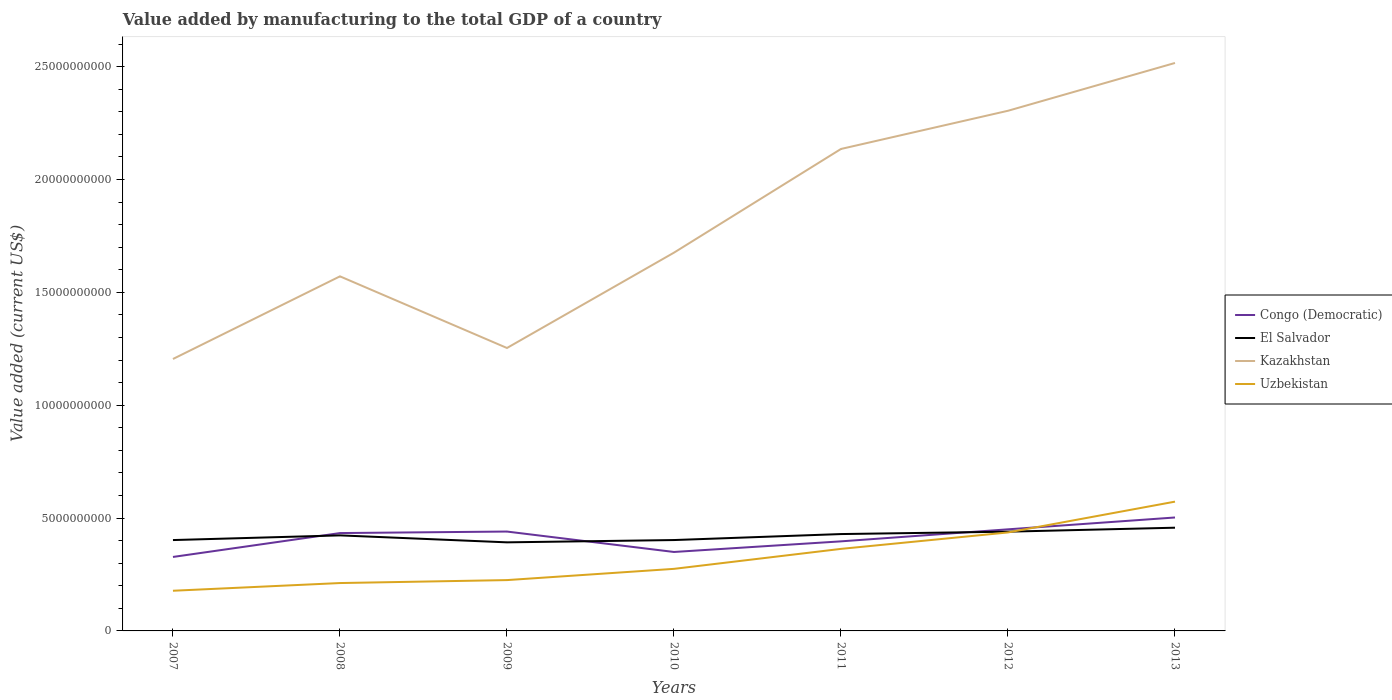Is the number of lines equal to the number of legend labels?
Offer a terse response. Yes. Across all years, what is the maximum value added by manufacturing to the total GDP in El Salvador?
Make the answer very short. 3.92e+09. What is the total value added by manufacturing to the total GDP in Congo (Democratic) in the graph?
Offer a terse response. -6.72e+07. What is the difference between the highest and the second highest value added by manufacturing to the total GDP in Kazakhstan?
Provide a succinct answer. 1.31e+1. Is the value added by manufacturing to the total GDP in El Salvador strictly greater than the value added by manufacturing to the total GDP in Uzbekistan over the years?
Ensure brevity in your answer.  No. How many lines are there?
Ensure brevity in your answer.  4. How many years are there in the graph?
Your answer should be compact. 7. What is the difference between two consecutive major ticks on the Y-axis?
Your answer should be very brief. 5.00e+09. Does the graph contain any zero values?
Provide a succinct answer. No. Does the graph contain grids?
Give a very brief answer. No. Where does the legend appear in the graph?
Give a very brief answer. Center right. What is the title of the graph?
Your answer should be compact. Value added by manufacturing to the total GDP of a country. What is the label or title of the X-axis?
Give a very brief answer. Years. What is the label or title of the Y-axis?
Your answer should be compact. Value added (current US$). What is the Value added (current US$) in Congo (Democratic) in 2007?
Provide a short and direct response. 3.28e+09. What is the Value added (current US$) in El Salvador in 2007?
Make the answer very short. 4.03e+09. What is the Value added (current US$) of Kazakhstan in 2007?
Your answer should be compact. 1.20e+1. What is the Value added (current US$) of Uzbekistan in 2007?
Offer a terse response. 1.78e+09. What is the Value added (current US$) in Congo (Democratic) in 2008?
Your answer should be compact. 4.34e+09. What is the Value added (current US$) of El Salvador in 2008?
Offer a terse response. 4.23e+09. What is the Value added (current US$) in Kazakhstan in 2008?
Your answer should be very brief. 1.57e+1. What is the Value added (current US$) in Uzbekistan in 2008?
Your response must be concise. 2.12e+09. What is the Value added (current US$) in Congo (Democratic) in 2009?
Your answer should be very brief. 4.40e+09. What is the Value added (current US$) of El Salvador in 2009?
Your response must be concise. 3.92e+09. What is the Value added (current US$) in Kazakhstan in 2009?
Ensure brevity in your answer.  1.25e+1. What is the Value added (current US$) of Uzbekistan in 2009?
Provide a succinct answer. 2.25e+09. What is the Value added (current US$) of Congo (Democratic) in 2010?
Your answer should be very brief. 3.50e+09. What is the Value added (current US$) in El Salvador in 2010?
Make the answer very short. 4.03e+09. What is the Value added (current US$) in Kazakhstan in 2010?
Ensure brevity in your answer.  1.68e+1. What is the Value added (current US$) in Uzbekistan in 2010?
Ensure brevity in your answer.  2.75e+09. What is the Value added (current US$) of Congo (Democratic) in 2011?
Your answer should be very brief. 3.97e+09. What is the Value added (current US$) of El Salvador in 2011?
Provide a short and direct response. 4.29e+09. What is the Value added (current US$) of Kazakhstan in 2011?
Your answer should be very brief. 2.14e+1. What is the Value added (current US$) in Uzbekistan in 2011?
Ensure brevity in your answer.  3.64e+09. What is the Value added (current US$) in Congo (Democratic) in 2012?
Make the answer very short. 4.50e+09. What is the Value added (current US$) of El Salvador in 2012?
Ensure brevity in your answer.  4.40e+09. What is the Value added (current US$) of Kazakhstan in 2012?
Your answer should be very brief. 2.30e+1. What is the Value added (current US$) of Uzbekistan in 2012?
Your response must be concise. 4.36e+09. What is the Value added (current US$) in Congo (Democratic) in 2013?
Offer a terse response. 5.03e+09. What is the Value added (current US$) in El Salvador in 2013?
Provide a succinct answer. 4.57e+09. What is the Value added (current US$) of Kazakhstan in 2013?
Offer a terse response. 2.52e+1. What is the Value added (current US$) in Uzbekistan in 2013?
Give a very brief answer. 5.73e+09. Across all years, what is the maximum Value added (current US$) in Congo (Democratic)?
Provide a succinct answer. 5.03e+09. Across all years, what is the maximum Value added (current US$) of El Salvador?
Keep it short and to the point. 4.57e+09. Across all years, what is the maximum Value added (current US$) in Kazakhstan?
Offer a very short reply. 2.52e+1. Across all years, what is the maximum Value added (current US$) of Uzbekistan?
Your answer should be compact. 5.73e+09. Across all years, what is the minimum Value added (current US$) in Congo (Democratic)?
Keep it short and to the point. 3.28e+09. Across all years, what is the minimum Value added (current US$) of El Salvador?
Your response must be concise. 3.92e+09. Across all years, what is the minimum Value added (current US$) of Kazakhstan?
Keep it short and to the point. 1.20e+1. Across all years, what is the minimum Value added (current US$) in Uzbekistan?
Provide a succinct answer. 1.78e+09. What is the total Value added (current US$) of Congo (Democratic) in the graph?
Your answer should be compact. 2.90e+1. What is the total Value added (current US$) in El Salvador in the graph?
Provide a short and direct response. 2.95e+1. What is the total Value added (current US$) in Kazakhstan in the graph?
Your answer should be very brief. 1.27e+11. What is the total Value added (current US$) in Uzbekistan in the graph?
Offer a very short reply. 2.26e+1. What is the difference between the Value added (current US$) of Congo (Democratic) in 2007 and that in 2008?
Your answer should be very brief. -1.06e+09. What is the difference between the Value added (current US$) in El Salvador in 2007 and that in 2008?
Your answer should be very brief. -2.08e+08. What is the difference between the Value added (current US$) of Kazakhstan in 2007 and that in 2008?
Your answer should be very brief. -3.66e+09. What is the difference between the Value added (current US$) in Uzbekistan in 2007 and that in 2008?
Provide a short and direct response. -3.41e+08. What is the difference between the Value added (current US$) of Congo (Democratic) in 2007 and that in 2009?
Provide a succinct answer. -1.13e+09. What is the difference between the Value added (current US$) in El Salvador in 2007 and that in 2009?
Keep it short and to the point. 1.01e+08. What is the difference between the Value added (current US$) in Kazakhstan in 2007 and that in 2009?
Keep it short and to the point. -4.88e+08. What is the difference between the Value added (current US$) in Uzbekistan in 2007 and that in 2009?
Offer a very short reply. -4.72e+08. What is the difference between the Value added (current US$) in Congo (Democratic) in 2007 and that in 2010?
Offer a very short reply. -2.21e+08. What is the difference between the Value added (current US$) of El Salvador in 2007 and that in 2010?
Give a very brief answer. -9.00e+05. What is the difference between the Value added (current US$) in Kazakhstan in 2007 and that in 2010?
Ensure brevity in your answer.  -4.71e+09. What is the difference between the Value added (current US$) in Uzbekistan in 2007 and that in 2010?
Provide a short and direct response. -9.70e+08. What is the difference between the Value added (current US$) of Congo (Democratic) in 2007 and that in 2011?
Offer a very short reply. -6.91e+08. What is the difference between the Value added (current US$) in El Salvador in 2007 and that in 2011?
Offer a terse response. -2.66e+08. What is the difference between the Value added (current US$) of Kazakhstan in 2007 and that in 2011?
Offer a terse response. -9.31e+09. What is the difference between the Value added (current US$) in Uzbekistan in 2007 and that in 2011?
Your response must be concise. -1.85e+09. What is the difference between the Value added (current US$) of Congo (Democratic) in 2007 and that in 2012?
Offer a very short reply. -1.22e+09. What is the difference between the Value added (current US$) of El Salvador in 2007 and that in 2012?
Offer a very short reply. -3.72e+08. What is the difference between the Value added (current US$) of Kazakhstan in 2007 and that in 2012?
Your answer should be compact. -1.10e+1. What is the difference between the Value added (current US$) in Uzbekistan in 2007 and that in 2012?
Provide a short and direct response. -2.58e+09. What is the difference between the Value added (current US$) of Congo (Democratic) in 2007 and that in 2013?
Offer a terse response. -1.75e+09. What is the difference between the Value added (current US$) of El Salvador in 2007 and that in 2013?
Offer a terse response. -5.48e+08. What is the difference between the Value added (current US$) in Kazakhstan in 2007 and that in 2013?
Provide a succinct answer. -1.31e+1. What is the difference between the Value added (current US$) of Uzbekistan in 2007 and that in 2013?
Provide a succinct answer. -3.95e+09. What is the difference between the Value added (current US$) of Congo (Democratic) in 2008 and that in 2009?
Your answer should be very brief. -6.72e+07. What is the difference between the Value added (current US$) in El Salvador in 2008 and that in 2009?
Keep it short and to the point. 3.09e+08. What is the difference between the Value added (current US$) of Kazakhstan in 2008 and that in 2009?
Your response must be concise. 3.17e+09. What is the difference between the Value added (current US$) in Uzbekistan in 2008 and that in 2009?
Keep it short and to the point. -1.31e+08. What is the difference between the Value added (current US$) in Congo (Democratic) in 2008 and that in 2010?
Provide a succinct answer. 8.37e+08. What is the difference between the Value added (current US$) of El Salvador in 2008 and that in 2010?
Offer a terse response. 2.07e+08. What is the difference between the Value added (current US$) in Kazakhstan in 2008 and that in 2010?
Ensure brevity in your answer.  -1.05e+09. What is the difference between the Value added (current US$) of Uzbekistan in 2008 and that in 2010?
Provide a succinct answer. -6.29e+08. What is the difference between the Value added (current US$) in Congo (Democratic) in 2008 and that in 2011?
Provide a short and direct response. 3.67e+08. What is the difference between the Value added (current US$) in El Salvador in 2008 and that in 2011?
Your answer should be very brief. -5.81e+07. What is the difference between the Value added (current US$) in Kazakhstan in 2008 and that in 2011?
Offer a very short reply. -5.64e+09. What is the difference between the Value added (current US$) in Uzbekistan in 2008 and that in 2011?
Your response must be concise. -1.51e+09. What is the difference between the Value added (current US$) of Congo (Democratic) in 2008 and that in 2012?
Your answer should be very brief. -1.66e+08. What is the difference between the Value added (current US$) of El Salvador in 2008 and that in 2012?
Give a very brief answer. -1.64e+08. What is the difference between the Value added (current US$) in Kazakhstan in 2008 and that in 2012?
Give a very brief answer. -7.34e+09. What is the difference between the Value added (current US$) in Uzbekistan in 2008 and that in 2012?
Ensure brevity in your answer.  -2.24e+09. What is the difference between the Value added (current US$) of Congo (Democratic) in 2008 and that in 2013?
Offer a very short reply. -6.91e+08. What is the difference between the Value added (current US$) of El Salvador in 2008 and that in 2013?
Your answer should be very brief. -3.40e+08. What is the difference between the Value added (current US$) of Kazakhstan in 2008 and that in 2013?
Offer a very short reply. -9.45e+09. What is the difference between the Value added (current US$) in Uzbekistan in 2008 and that in 2013?
Give a very brief answer. -3.61e+09. What is the difference between the Value added (current US$) in Congo (Democratic) in 2009 and that in 2010?
Provide a short and direct response. 9.05e+08. What is the difference between the Value added (current US$) of El Salvador in 2009 and that in 2010?
Provide a short and direct response. -1.02e+08. What is the difference between the Value added (current US$) in Kazakhstan in 2009 and that in 2010?
Your response must be concise. -4.22e+09. What is the difference between the Value added (current US$) of Uzbekistan in 2009 and that in 2010?
Your answer should be compact. -4.98e+08. What is the difference between the Value added (current US$) in Congo (Democratic) in 2009 and that in 2011?
Offer a very short reply. 4.34e+08. What is the difference between the Value added (current US$) of El Salvador in 2009 and that in 2011?
Give a very brief answer. -3.67e+08. What is the difference between the Value added (current US$) in Kazakhstan in 2009 and that in 2011?
Your answer should be very brief. -8.82e+09. What is the difference between the Value added (current US$) in Uzbekistan in 2009 and that in 2011?
Your answer should be compact. -1.38e+09. What is the difference between the Value added (current US$) of Congo (Democratic) in 2009 and that in 2012?
Your answer should be very brief. -9.88e+07. What is the difference between the Value added (current US$) in El Salvador in 2009 and that in 2012?
Your answer should be compact. -4.73e+08. What is the difference between the Value added (current US$) in Kazakhstan in 2009 and that in 2012?
Provide a succinct answer. -1.05e+1. What is the difference between the Value added (current US$) in Uzbekistan in 2009 and that in 2012?
Give a very brief answer. -2.11e+09. What is the difference between the Value added (current US$) of Congo (Democratic) in 2009 and that in 2013?
Your answer should be very brief. -6.24e+08. What is the difference between the Value added (current US$) of El Salvador in 2009 and that in 2013?
Your answer should be very brief. -6.49e+08. What is the difference between the Value added (current US$) in Kazakhstan in 2009 and that in 2013?
Your answer should be very brief. -1.26e+1. What is the difference between the Value added (current US$) in Uzbekistan in 2009 and that in 2013?
Provide a succinct answer. -3.48e+09. What is the difference between the Value added (current US$) in Congo (Democratic) in 2010 and that in 2011?
Your answer should be compact. -4.70e+08. What is the difference between the Value added (current US$) of El Salvador in 2010 and that in 2011?
Ensure brevity in your answer.  -2.65e+08. What is the difference between the Value added (current US$) of Kazakhstan in 2010 and that in 2011?
Provide a succinct answer. -4.59e+09. What is the difference between the Value added (current US$) of Uzbekistan in 2010 and that in 2011?
Offer a very short reply. -8.85e+08. What is the difference between the Value added (current US$) of Congo (Democratic) in 2010 and that in 2012?
Provide a short and direct response. -1.00e+09. What is the difference between the Value added (current US$) of El Salvador in 2010 and that in 2012?
Your response must be concise. -3.71e+08. What is the difference between the Value added (current US$) of Kazakhstan in 2010 and that in 2012?
Offer a terse response. -6.29e+09. What is the difference between the Value added (current US$) in Uzbekistan in 2010 and that in 2012?
Provide a short and direct response. -1.61e+09. What is the difference between the Value added (current US$) of Congo (Democratic) in 2010 and that in 2013?
Offer a terse response. -1.53e+09. What is the difference between the Value added (current US$) of El Salvador in 2010 and that in 2013?
Provide a short and direct response. -5.47e+08. What is the difference between the Value added (current US$) of Kazakhstan in 2010 and that in 2013?
Make the answer very short. -8.41e+09. What is the difference between the Value added (current US$) in Uzbekistan in 2010 and that in 2013?
Offer a very short reply. -2.98e+09. What is the difference between the Value added (current US$) of Congo (Democratic) in 2011 and that in 2012?
Your response must be concise. -5.33e+08. What is the difference between the Value added (current US$) of El Salvador in 2011 and that in 2012?
Offer a terse response. -1.06e+08. What is the difference between the Value added (current US$) in Kazakhstan in 2011 and that in 2012?
Offer a very short reply. -1.69e+09. What is the difference between the Value added (current US$) in Uzbekistan in 2011 and that in 2012?
Ensure brevity in your answer.  -7.29e+08. What is the difference between the Value added (current US$) in Congo (Democratic) in 2011 and that in 2013?
Ensure brevity in your answer.  -1.06e+09. What is the difference between the Value added (current US$) in El Salvador in 2011 and that in 2013?
Provide a succinct answer. -2.82e+08. What is the difference between the Value added (current US$) in Kazakhstan in 2011 and that in 2013?
Provide a short and direct response. -3.81e+09. What is the difference between the Value added (current US$) of Uzbekistan in 2011 and that in 2013?
Give a very brief answer. -2.09e+09. What is the difference between the Value added (current US$) of Congo (Democratic) in 2012 and that in 2013?
Your response must be concise. -5.25e+08. What is the difference between the Value added (current US$) of El Salvador in 2012 and that in 2013?
Your answer should be compact. -1.76e+08. What is the difference between the Value added (current US$) of Kazakhstan in 2012 and that in 2013?
Your answer should be very brief. -2.12e+09. What is the difference between the Value added (current US$) of Uzbekistan in 2012 and that in 2013?
Give a very brief answer. -1.36e+09. What is the difference between the Value added (current US$) of Congo (Democratic) in 2007 and the Value added (current US$) of El Salvador in 2008?
Offer a very short reply. -9.56e+08. What is the difference between the Value added (current US$) of Congo (Democratic) in 2007 and the Value added (current US$) of Kazakhstan in 2008?
Your answer should be very brief. -1.24e+1. What is the difference between the Value added (current US$) of Congo (Democratic) in 2007 and the Value added (current US$) of Uzbekistan in 2008?
Make the answer very short. 1.16e+09. What is the difference between the Value added (current US$) of El Salvador in 2007 and the Value added (current US$) of Kazakhstan in 2008?
Offer a very short reply. -1.17e+1. What is the difference between the Value added (current US$) of El Salvador in 2007 and the Value added (current US$) of Uzbekistan in 2008?
Provide a short and direct response. 1.90e+09. What is the difference between the Value added (current US$) of Kazakhstan in 2007 and the Value added (current US$) of Uzbekistan in 2008?
Ensure brevity in your answer.  9.93e+09. What is the difference between the Value added (current US$) in Congo (Democratic) in 2007 and the Value added (current US$) in El Salvador in 2009?
Your answer should be very brief. -6.47e+08. What is the difference between the Value added (current US$) in Congo (Democratic) in 2007 and the Value added (current US$) in Kazakhstan in 2009?
Ensure brevity in your answer.  -9.26e+09. What is the difference between the Value added (current US$) of Congo (Democratic) in 2007 and the Value added (current US$) of Uzbekistan in 2009?
Your answer should be compact. 1.03e+09. What is the difference between the Value added (current US$) of El Salvador in 2007 and the Value added (current US$) of Kazakhstan in 2009?
Provide a succinct answer. -8.51e+09. What is the difference between the Value added (current US$) in El Salvador in 2007 and the Value added (current US$) in Uzbekistan in 2009?
Offer a terse response. 1.77e+09. What is the difference between the Value added (current US$) of Kazakhstan in 2007 and the Value added (current US$) of Uzbekistan in 2009?
Your answer should be very brief. 9.80e+09. What is the difference between the Value added (current US$) of Congo (Democratic) in 2007 and the Value added (current US$) of El Salvador in 2010?
Ensure brevity in your answer.  -7.49e+08. What is the difference between the Value added (current US$) of Congo (Democratic) in 2007 and the Value added (current US$) of Kazakhstan in 2010?
Your answer should be compact. -1.35e+1. What is the difference between the Value added (current US$) of Congo (Democratic) in 2007 and the Value added (current US$) of Uzbekistan in 2010?
Keep it short and to the point. 5.27e+08. What is the difference between the Value added (current US$) of El Salvador in 2007 and the Value added (current US$) of Kazakhstan in 2010?
Your answer should be compact. -1.27e+1. What is the difference between the Value added (current US$) of El Salvador in 2007 and the Value added (current US$) of Uzbekistan in 2010?
Give a very brief answer. 1.28e+09. What is the difference between the Value added (current US$) in Kazakhstan in 2007 and the Value added (current US$) in Uzbekistan in 2010?
Your response must be concise. 9.30e+09. What is the difference between the Value added (current US$) of Congo (Democratic) in 2007 and the Value added (current US$) of El Salvador in 2011?
Give a very brief answer. -1.01e+09. What is the difference between the Value added (current US$) of Congo (Democratic) in 2007 and the Value added (current US$) of Kazakhstan in 2011?
Offer a very short reply. -1.81e+1. What is the difference between the Value added (current US$) in Congo (Democratic) in 2007 and the Value added (current US$) in Uzbekistan in 2011?
Your answer should be very brief. -3.57e+08. What is the difference between the Value added (current US$) in El Salvador in 2007 and the Value added (current US$) in Kazakhstan in 2011?
Your response must be concise. -1.73e+1. What is the difference between the Value added (current US$) of El Salvador in 2007 and the Value added (current US$) of Uzbekistan in 2011?
Make the answer very short. 3.91e+08. What is the difference between the Value added (current US$) in Kazakhstan in 2007 and the Value added (current US$) in Uzbekistan in 2011?
Offer a very short reply. 8.41e+09. What is the difference between the Value added (current US$) of Congo (Democratic) in 2007 and the Value added (current US$) of El Salvador in 2012?
Offer a terse response. -1.12e+09. What is the difference between the Value added (current US$) in Congo (Democratic) in 2007 and the Value added (current US$) in Kazakhstan in 2012?
Keep it short and to the point. -1.98e+1. What is the difference between the Value added (current US$) of Congo (Democratic) in 2007 and the Value added (current US$) of Uzbekistan in 2012?
Offer a terse response. -1.09e+09. What is the difference between the Value added (current US$) of El Salvador in 2007 and the Value added (current US$) of Kazakhstan in 2012?
Give a very brief answer. -1.90e+1. What is the difference between the Value added (current US$) in El Salvador in 2007 and the Value added (current US$) in Uzbekistan in 2012?
Ensure brevity in your answer.  -3.38e+08. What is the difference between the Value added (current US$) of Kazakhstan in 2007 and the Value added (current US$) of Uzbekistan in 2012?
Your response must be concise. 7.69e+09. What is the difference between the Value added (current US$) of Congo (Democratic) in 2007 and the Value added (current US$) of El Salvador in 2013?
Keep it short and to the point. -1.30e+09. What is the difference between the Value added (current US$) of Congo (Democratic) in 2007 and the Value added (current US$) of Kazakhstan in 2013?
Give a very brief answer. -2.19e+1. What is the difference between the Value added (current US$) of Congo (Democratic) in 2007 and the Value added (current US$) of Uzbekistan in 2013?
Your answer should be compact. -2.45e+09. What is the difference between the Value added (current US$) of El Salvador in 2007 and the Value added (current US$) of Kazakhstan in 2013?
Give a very brief answer. -2.11e+1. What is the difference between the Value added (current US$) of El Salvador in 2007 and the Value added (current US$) of Uzbekistan in 2013?
Ensure brevity in your answer.  -1.70e+09. What is the difference between the Value added (current US$) in Kazakhstan in 2007 and the Value added (current US$) in Uzbekistan in 2013?
Your answer should be very brief. 6.32e+09. What is the difference between the Value added (current US$) in Congo (Democratic) in 2008 and the Value added (current US$) in El Salvador in 2009?
Offer a very short reply. 4.11e+08. What is the difference between the Value added (current US$) of Congo (Democratic) in 2008 and the Value added (current US$) of Kazakhstan in 2009?
Give a very brief answer. -8.20e+09. What is the difference between the Value added (current US$) in Congo (Democratic) in 2008 and the Value added (current US$) in Uzbekistan in 2009?
Your response must be concise. 2.08e+09. What is the difference between the Value added (current US$) in El Salvador in 2008 and the Value added (current US$) in Kazakhstan in 2009?
Keep it short and to the point. -8.30e+09. What is the difference between the Value added (current US$) in El Salvador in 2008 and the Value added (current US$) in Uzbekistan in 2009?
Provide a succinct answer. 1.98e+09. What is the difference between the Value added (current US$) of Kazakhstan in 2008 and the Value added (current US$) of Uzbekistan in 2009?
Ensure brevity in your answer.  1.35e+1. What is the difference between the Value added (current US$) in Congo (Democratic) in 2008 and the Value added (current US$) in El Salvador in 2010?
Provide a succinct answer. 3.09e+08. What is the difference between the Value added (current US$) of Congo (Democratic) in 2008 and the Value added (current US$) of Kazakhstan in 2010?
Offer a very short reply. -1.24e+1. What is the difference between the Value added (current US$) in Congo (Democratic) in 2008 and the Value added (current US$) in Uzbekistan in 2010?
Your answer should be very brief. 1.59e+09. What is the difference between the Value added (current US$) of El Salvador in 2008 and the Value added (current US$) of Kazakhstan in 2010?
Your answer should be very brief. -1.25e+1. What is the difference between the Value added (current US$) of El Salvador in 2008 and the Value added (current US$) of Uzbekistan in 2010?
Your answer should be very brief. 1.48e+09. What is the difference between the Value added (current US$) in Kazakhstan in 2008 and the Value added (current US$) in Uzbekistan in 2010?
Give a very brief answer. 1.30e+1. What is the difference between the Value added (current US$) of Congo (Democratic) in 2008 and the Value added (current US$) of El Salvador in 2011?
Give a very brief answer. 4.42e+07. What is the difference between the Value added (current US$) in Congo (Democratic) in 2008 and the Value added (current US$) in Kazakhstan in 2011?
Your answer should be very brief. -1.70e+1. What is the difference between the Value added (current US$) of Congo (Democratic) in 2008 and the Value added (current US$) of Uzbekistan in 2011?
Give a very brief answer. 7.01e+08. What is the difference between the Value added (current US$) of El Salvador in 2008 and the Value added (current US$) of Kazakhstan in 2011?
Provide a succinct answer. -1.71e+1. What is the difference between the Value added (current US$) in El Salvador in 2008 and the Value added (current US$) in Uzbekistan in 2011?
Provide a short and direct response. 5.98e+08. What is the difference between the Value added (current US$) in Kazakhstan in 2008 and the Value added (current US$) in Uzbekistan in 2011?
Keep it short and to the point. 1.21e+1. What is the difference between the Value added (current US$) of Congo (Democratic) in 2008 and the Value added (current US$) of El Salvador in 2012?
Make the answer very short. -6.17e+07. What is the difference between the Value added (current US$) in Congo (Democratic) in 2008 and the Value added (current US$) in Kazakhstan in 2012?
Provide a short and direct response. -1.87e+1. What is the difference between the Value added (current US$) in Congo (Democratic) in 2008 and the Value added (current US$) in Uzbekistan in 2012?
Provide a short and direct response. -2.77e+07. What is the difference between the Value added (current US$) in El Salvador in 2008 and the Value added (current US$) in Kazakhstan in 2012?
Your answer should be very brief. -1.88e+1. What is the difference between the Value added (current US$) of El Salvador in 2008 and the Value added (current US$) of Uzbekistan in 2012?
Provide a succinct answer. -1.30e+08. What is the difference between the Value added (current US$) in Kazakhstan in 2008 and the Value added (current US$) in Uzbekistan in 2012?
Ensure brevity in your answer.  1.13e+1. What is the difference between the Value added (current US$) in Congo (Democratic) in 2008 and the Value added (current US$) in El Salvador in 2013?
Make the answer very short. -2.38e+08. What is the difference between the Value added (current US$) of Congo (Democratic) in 2008 and the Value added (current US$) of Kazakhstan in 2013?
Offer a terse response. -2.08e+1. What is the difference between the Value added (current US$) in Congo (Democratic) in 2008 and the Value added (current US$) in Uzbekistan in 2013?
Your answer should be very brief. -1.39e+09. What is the difference between the Value added (current US$) of El Salvador in 2008 and the Value added (current US$) of Kazakhstan in 2013?
Give a very brief answer. -2.09e+1. What is the difference between the Value added (current US$) in El Salvador in 2008 and the Value added (current US$) in Uzbekistan in 2013?
Provide a succinct answer. -1.49e+09. What is the difference between the Value added (current US$) of Kazakhstan in 2008 and the Value added (current US$) of Uzbekistan in 2013?
Make the answer very short. 9.98e+09. What is the difference between the Value added (current US$) in Congo (Democratic) in 2009 and the Value added (current US$) in El Salvador in 2010?
Provide a succinct answer. 3.76e+08. What is the difference between the Value added (current US$) in Congo (Democratic) in 2009 and the Value added (current US$) in Kazakhstan in 2010?
Keep it short and to the point. -1.24e+1. What is the difference between the Value added (current US$) of Congo (Democratic) in 2009 and the Value added (current US$) of Uzbekistan in 2010?
Provide a succinct answer. 1.65e+09. What is the difference between the Value added (current US$) in El Salvador in 2009 and the Value added (current US$) in Kazakhstan in 2010?
Make the answer very short. -1.28e+1. What is the difference between the Value added (current US$) in El Salvador in 2009 and the Value added (current US$) in Uzbekistan in 2010?
Make the answer very short. 1.17e+09. What is the difference between the Value added (current US$) in Kazakhstan in 2009 and the Value added (current US$) in Uzbekistan in 2010?
Your response must be concise. 9.79e+09. What is the difference between the Value added (current US$) of Congo (Democratic) in 2009 and the Value added (current US$) of El Salvador in 2011?
Ensure brevity in your answer.  1.11e+08. What is the difference between the Value added (current US$) of Congo (Democratic) in 2009 and the Value added (current US$) of Kazakhstan in 2011?
Your answer should be very brief. -1.70e+1. What is the difference between the Value added (current US$) of Congo (Democratic) in 2009 and the Value added (current US$) of Uzbekistan in 2011?
Keep it short and to the point. 7.68e+08. What is the difference between the Value added (current US$) of El Salvador in 2009 and the Value added (current US$) of Kazakhstan in 2011?
Make the answer very short. -1.74e+1. What is the difference between the Value added (current US$) in El Salvador in 2009 and the Value added (current US$) in Uzbekistan in 2011?
Provide a short and direct response. 2.90e+08. What is the difference between the Value added (current US$) in Kazakhstan in 2009 and the Value added (current US$) in Uzbekistan in 2011?
Your response must be concise. 8.90e+09. What is the difference between the Value added (current US$) of Congo (Democratic) in 2009 and the Value added (current US$) of El Salvador in 2012?
Ensure brevity in your answer.  5.52e+06. What is the difference between the Value added (current US$) of Congo (Democratic) in 2009 and the Value added (current US$) of Kazakhstan in 2012?
Provide a succinct answer. -1.86e+1. What is the difference between the Value added (current US$) in Congo (Democratic) in 2009 and the Value added (current US$) in Uzbekistan in 2012?
Keep it short and to the point. 3.95e+07. What is the difference between the Value added (current US$) of El Salvador in 2009 and the Value added (current US$) of Kazakhstan in 2012?
Make the answer very short. -1.91e+1. What is the difference between the Value added (current US$) in El Salvador in 2009 and the Value added (current US$) in Uzbekistan in 2012?
Ensure brevity in your answer.  -4.39e+08. What is the difference between the Value added (current US$) in Kazakhstan in 2009 and the Value added (current US$) in Uzbekistan in 2012?
Your response must be concise. 8.17e+09. What is the difference between the Value added (current US$) of Congo (Democratic) in 2009 and the Value added (current US$) of El Salvador in 2013?
Keep it short and to the point. -1.71e+08. What is the difference between the Value added (current US$) in Congo (Democratic) in 2009 and the Value added (current US$) in Kazakhstan in 2013?
Provide a short and direct response. -2.08e+1. What is the difference between the Value added (current US$) in Congo (Democratic) in 2009 and the Value added (current US$) in Uzbekistan in 2013?
Your answer should be compact. -1.33e+09. What is the difference between the Value added (current US$) of El Salvador in 2009 and the Value added (current US$) of Kazakhstan in 2013?
Your answer should be very brief. -2.12e+1. What is the difference between the Value added (current US$) in El Salvador in 2009 and the Value added (current US$) in Uzbekistan in 2013?
Provide a short and direct response. -1.80e+09. What is the difference between the Value added (current US$) in Kazakhstan in 2009 and the Value added (current US$) in Uzbekistan in 2013?
Make the answer very short. 6.81e+09. What is the difference between the Value added (current US$) of Congo (Democratic) in 2010 and the Value added (current US$) of El Salvador in 2011?
Your answer should be very brief. -7.93e+08. What is the difference between the Value added (current US$) of Congo (Democratic) in 2010 and the Value added (current US$) of Kazakhstan in 2011?
Your response must be concise. -1.79e+1. What is the difference between the Value added (current US$) of Congo (Democratic) in 2010 and the Value added (current US$) of Uzbekistan in 2011?
Provide a succinct answer. -1.37e+08. What is the difference between the Value added (current US$) in El Salvador in 2010 and the Value added (current US$) in Kazakhstan in 2011?
Offer a terse response. -1.73e+1. What is the difference between the Value added (current US$) of El Salvador in 2010 and the Value added (current US$) of Uzbekistan in 2011?
Provide a succinct answer. 3.92e+08. What is the difference between the Value added (current US$) in Kazakhstan in 2010 and the Value added (current US$) in Uzbekistan in 2011?
Offer a very short reply. 1.31e+1. What is the difference between the Value added (current US$) in Congo (Democratic) in 2010 and the Value added (current US$) in El Salvador in 2012?
Ensure brevity in your answer.  -8.99e+08. What is the difference between the Value added (current US$) in Congo (Democratic) in 2010 and the Value added (current US$) in Kazakhstan in 2012?
Offer a very short reply. -1.95e+1. What is the difference between the Value added (current US$) of Congo (Democratic) in 2010 and the Value added (current US$) of Uzbekistan in 2012?
Give a very brief answer. -8.65e+08. What is the difference between the Value added (current US$) of El Salvador in 2010 and the Value added (current US$) of Kazakhstan in 2012?
Your answer should be very brief. -1.90e+1. What is the difference between the Value added (current US$) of El Salvador in 2010 and the Value added (current US$) of Uzbekistan in 2012?
Offer a terse response. -3.37e+08. What is the difference between the Value added (current US$) of Kazakhstan in 2010 and the Value added (current US$) of Uzbekistan in 2012?
Ensure brevity in your answer.  1.24e+1. What is the difference between the Value added (current US$) of Congo (Democratic) in 2010 and the Value added (current US$) of El Salvador in 2013?
Your answer should be compact. -1.08e+09. What is the difference between the Value added (current US$) in Congo (Democratic) in 2010 and the Value added (current US$) in Kazakhstan in 2013?
Make the answer very short. -2.17e+1. What is the difference between the Value added (current US$) of Congo (Democratic) in 2010 and the Value added (current US$) of Uzbekistan in 2013?
Offer a very short reply. -2.23e+09. What is the difference between the Value added (current US$) of El Salvador in 2010 and the Value added (current US$) of Kazakhstan in 2013?
Offer a very short reply. -2.11e+1. What is the difference between the Value added (current US$) of El Salvador in 2010 and the Value added (current US$) of Uzbekistan in 2013?
Provide a succinct answer. -1.70e+09. What is the difference between the Value added (current US$) of Kazakhstan in 2010 and the Value added (current US$) of Uzbekistan in 2013?
Offer a very short reply. 1.10e+1. What is the difference between the Value added (current US$) of Congo (Democratic) in 2011 and the Value added (current US$) of El Salvador in 2012?
Offer a very short reply. -4.29e+08. What is the difference between the Value added (current US$) of Congo (Democratic) in 2011 and the Value added (current US$) of Kazakhstan in 2012?
Keep it short and to the point. -1.91e+1. What is the difference between the Value added (current US$) in Congo (Democratic) in 2011 and the Value added (current US$) in Uzbekistan in 2012?
Make the answer very short. -3.95e+08. What is the difference between the Value added (current US$) in El Salvador in 2011 and the Value added (current US$) in Kazakhstan in 2012?
Provide a short and direct response. -1.88e+1. What is the difference between the Value added (current US$) of El Salvador in 2011 and the Value added (current US$) of Uzbekistan in 2012?
Provide a succinct answer. -7.20e+07. What is the difference between the Value added (current US$) in Kazakhstan in 2011 and the Value added (current US$) in Uzbekistan in 2012?
Offer a very short reply. 1.70e+1. What is the difference between the Value added (current US$) in Congo (Democratic) in 2011 and the Value added (current US$) in El Salvador in 2013?
Offer a terse response. -6.05e+08. What is the difference between the Value added (current US$) of Congo (Democratic) in 2011 and the Value added (current US$) of Kazakhstan in 2013?
Make the answer very short. -2.12e+1. What is the difference between the Value added (current US$) in Congo (Democratic) in 2011 and the Value added (current US$) in Uzbekistan in 2013?
Your answer should be very brief. -1.76e+09. What is the difference between the Value added (current US$) of El Salvador in 2011 and the Value added (current US$) of Kazakhstan in 2013?
Ensure brevity in your answer.  -2.09e+1. What is the difference between the Value added (current US$) of El Salvador in 2011 and the Value added (current US$) of Uzbekistan in 2013?
Your answer should be compact. -1.44e+09. What is the difference between the Value added (current US$) in Kazakhstan in 2011 and the Value added (current US$) in Uzbekistan in 2013?
Your answer should be very brief. 1.56e+1. What is the difference between the Value added (current US$) in Congo (Democratic) in 2012 and the Value added (current US$) in El Salvador in 2013?
Keep it short and to the point. -7.18e+07. What is the difference between the Value added (current US$) of Congo (Democratic) in 2012 and the Value added (current US$) of Kazakhstan in 2013?
Give a very brief answer. -2.07e+1. What is the difference between the Value added (current US$) of Congo (Democratic) in 2012 and the Value added (current US$) of Uzbekistan in 2013?
Offer a very short reply. -1.23e+09. What is the difference between the Value added (current US$) of El Salvador in 2012 and the Value added (current US$) of Kazakhstan in 2013?
Make the answer very short. -2.08e+1. What is the difference between the Value added (current US$) in El Salvador in 2012 and the Value added (current US$) in Uzbekistan in 2013?
Offer a terse response. -1.33e+09. What is the difference between the Value added (current US$) of Kazakhstan in 2012 and the Value added (current US$) of Uzbekistan in 2013?
Your answer should be compact. 1.73e+1. What is the average Value added (current US$) in Congo (Democratic) per year?
Provide a short and direct response. 4.14e+09. What is the average Value added (current US$) in El Salvador per year?
Offer a very short reply. 4.21e+09. What is the average Value added (current US$) in Kazakhstan per year?
Provide a succinct answer. 1.81e+1. What is the average Value added (current US$) of Uzbekistan per year?
Ensure brevity in your answer.  3.23e+09. In the year 2007, what is the difference between the Value added (current US$) in Congo (Democratic) and Value added (current US$) in El Salvador?
Make the answer very short. -7.48e+08. In the year 2007, what is the difference between the Value added (current US$) of Congo (Democratic) and Value added (current US$) of Kazakhstan?
Provide a short and direct response. -8.77e+09. In the year 2007, what is the difference between the Value added (current US$) of Congo (Democratic) and Value added (current US$) of Uzbekistan?
Give a very brief answer. 1.50e+09. In the year 2007, what is the difference between the Value added (current US$) of El Salvador and Value added (current US$) of Kazakhstan?
Your answer should be compact. -8.02e+09. In the year 2007, what is the difference between the Value added (current US$) in El Salvador and Value added (current US$) in Uzbekistan?
Offer a terse response. 2.25e+09. In the year 2007, what is the difference between the Value added (current US$) of Kazakhstan and Value added (current US$) of Uzbekistan?
Your answer should be very brief. 1.03e+1. In the year 2008, what is the difference between the Value added (current US$) in Congo (Democratic) and Value added (current US$) in El Salvador?
Offer a very short reply. 1.02e+08. In the year 2008, what is the difference between the Value added (current US$) in Congo (Democratic) and Value added (current US$) in Kazakhstan?
Your answer should be very brief. -1.14e+1. In the year 2008, what is the difference between the Value added (current US$) in Congo (Democratic) and Value added (current US$) in Uzbekistan?
Keep it short and to the point. 2.21e+09. In the year 2008, what is the difference between the Value added (current US$) in El Salvador and Value added (current US$) in Kazakhstan?
Give a very brief answer. -1.15e+1. In the year 2008, what is the difference between the Value added (current US$) of El Salvador and Value added (current US$) of Uzbekistan?
Give a very brief answer. 2.11e+09. In the year 2008, what is the difference between the Value added (current US$) in Kazakhstan and Value added (current US$) in Uzbekistan?
Ensure brevity in your answer.  1.36e+1. In the year 2009, what is the difference between the Value added (current US$) in Congo (Democratic) and Value added (current US$) in El Salvador?
Make the answer very short. 4.78e+08. In the year 2009, what is the difference between the Value added (current US$) in Congo (Democratic) and Value added (current US$) in Kazakhstan?
Give a very brief answer. -8.13e+09. In the year 2009, what is the difference between the Value added (current US$) of Congo (Democratic) and Value added (current US$) of Uzbekistan?
Your answer should be very brief. 2.15e+09. In the year 2009, what is the difference between the Value added (current US$) in El Salvador and Value added (current US$) in Kazakhstan?
Provide a short and direct response. -8.61e+09. In the year 2009, what is the difference between the Value added (current US$) of El Salvador and Value added (current US$) of Uzbekistan?
Offer a very short reply. 1.67e+09. In the year 2009, what is the difference between the Value added (current US$) of Kazakhstan and Value added (current US$) of Uzbekistan?
Your answer should be compact. 1.03e+1. In the year 2010, what is the difference between the Value added (current US$) in Congo (Democratic) and Value added (current US$) in El Salvador?
Keep it short and to the point. -5.29e+08. In the year 2010, what is the difference between the Value added (current US$) in Congo (Democratic) and Value added (current US$) in Kazakhstan?
Offer a terse response. -1.33e+1. In the year 2010, what is the difference between the Value added (current US$) of Congo (Democratic) and Value added (current US$) of Uzbekistan?
Your answer should be very brief. 7.48e+08. In the year 2010, what is the difference between the Value added (current US$) of El Salvador and Value added (current US$) of Kazakhstan?
Provide a short and direct response. -1.27e+1. In the year 2010, what is the difference between the Value added (current US$) of El Salvador and Value added (current US$) of Uzbekistan?
Give a very brief answer. 1.28e+09. In the year 2010, what is the difference between the Value added (current US$) of Kazakhstan and Value added (current US$) of Uzbekistan?
Offer a terse response. 1.40e+1. In the year 2011, what is the difference between the Value added (current US$) of Congo (Democratic) and Value added (current US$) of El Salvador?
Provide a short and direct response. -3.23e+08. In the year 2011, what is the difference between the Value added (current US$) in Congo (Democratic) and Value added (current US$) in Kazakhstan?
Keep it short and to the point. -1.74e+1. In the year 2011, what is the difference between the Value added (current US$) in Congo (Democratic) and Value added (current US$) in Uzbekistan?
Give a very brief answer. 3.34e+08. In the year 2011, what is the difference between the Value added (current US$) of El Salvador and Value added (current US$) of Kazakhstan?
Your answer should be very brief. -1.71e+1. In the year 2011, what is the difference between the Value added (current US$) in El Salvador and Value added (current US$) in Uzbekistan?
Ensure brevity in your answer.  6.57e+08. In the year 2011, what is the difference between the Value added (current US$) of Kazakhstan and Value added (current US$) of Uzbekistan?
Your answer should be very brief. 1.77e+1. In the year 2012, what is the difference between the Value added (current US$) of Congo (Democratic) and Value added (current US$) of El Salvador?
Your answer should be compact. 1.04e+08. In the year 2012, what is the difference between the Value added (current US$) in Congo (Democratic) and Value added (current US$) in Kazakhstan?
Make the answer very short. -1.85e+1. In the year 2012, what is the difference between the Value added (current US$) of Congo (Democratic) and Value added (current US$) of Uzbekistan?
Provide a short and direct response. 1.38e+08. In the year 2012, what is the difference between the Value added (current US$) of El Salvador and Value added (current US$) of Kazakhstan?
Your answer should be very brief. -1.87e+1. In the year 2012, what is the difference between the Value added (current US$) in El Salvador and Value added (current US$) in Uzbekistan?
Make the answer very short. 3.39e+07. In the year 2012, what is the difference between the Value added (current US$) of Kazakhstan and Value added (current US$) of Uzbekistan?
Your answer should be very brief. 1.87e+1. In the year 2013, what is the difference between the Value added (current US$) in Congo (Democratic) and Value added (current US$) in El Salvador?
Provide a short and direct response. 4.53e+08. In the year 2013, what is the difference between the Value added (current US$) of Congo (Democratic) and Value added (current US$) of Kazakhstan?
Keep it short and to the point. -2.01e+1. In the year 2013, what is the difference between the Value added (current US$) in Congo (Democratic) and Value added (current US$) in Uzbekistan?
Your answer should be very brief. -7.02e+08. In the year 2013, what is the difference between the Value added (current US$) of El Salvador and Value added (current US$) of Kazakhstan?
Keep it short and to the point. -2.06e+1. In the year 2013, what is the difference between the Value added (current US$) in El Salvador and Value added (current US$) in Uzbekistan?
Offer a very short reply. -1.15e+09. In the year 2013, what is the difference between the Value added (current US$) of Kazakhstan and Value added (current US$) of Uzbekistan?
Make the answer very short. 1.94e+1. What is the ratio of the Value added (current US$) of Congo (Democratic) in 2007 to that in 2008?
Offer a very short reply. 0.76. What is the ratio of the Value added (current US$) in El Salvador in 2007 to that in 2008?
Your answer should be compact. 0.95. What is the ratio of the Value added (current US$) of Kazakhstan in 2007 to that in 2008?
Your answer should be compact. 0.77. What is the ratio of the Value added (current US$) in Uzbekistan in 2007 to that in 2008?
Ensure brevity in your answer.  0.84. What is the ratio of the Value added (current US$) of Congo (Democratic) in 2007 to that in 2009?
Give a very brief answer. 0.74. What is the ratio of the Value added (current US$) of El Salvador in 2007 to that in 2009?
Provide a short and direct response. 1.03. What is the ratio of the Value added (current US$) in Kazakhstan in 2007 to that in 2009?
Offer a terse response. 0.96. What is the ratio of the Value added (current US$) of Uzbekistan in 2007 to that in 2009?
Offer a terse response. 0.79. What is the ratio of the Value added (current US$) in Congo (Democratic) in 2007 to that in 2010?
Provide a succinct answer. 0.94. What is the ratio of the Value added (current US$) of El Salvador in 2007 to that in 2010?
Your answer should be compact. 1. What is the ratio of the Value added (current US$) in Kazakhstan in 2007 to that in 2010?
Provide a succinct answer. 0.72. What is the ratio of the Value added (current US$) of Uzbekistan in 2007 to that in 2010?
Offer a very short reply. 0.65. What is the ratio of the Value added (current US$) in Congo (Democratic) in 2007 to that in 2011?
Your answer should be very brief. 0.83. What is the ratio of the Value added (current US$) in El Salvador in 2007 to that in 2011?
Provide a succinct answer. 0.94. What is the ratio of the Value added (current US$) of Kazakhstan in 2007 to that in 2011?
Offer a very short reply. 0.56. What is the ratio of the Value added (current US$) in Uzbekistan in 2007 to that in 2011?
Offer a very short reply. 0.49. What is the ratio of the Value added (current US$) in Congo (Democratic) in 2007 to that in 2012?
Ensure brevity in your answer.  0.73. What is the ratio of the Value added (current US$) in El Salvador in 2007 to that in 2012?
Give a very brief answer. 0.92. What is the ratio of the Value added (current US$) in Kazakhstan in 2007 to that in 2012?
Your response must be concise. 0.52. What is the ratio of the Value added (current US$) of Uzbekistan in 2007 to that in 2012?
Provide a succinct answer. 0.41. What is the ratio of the Value added (current US$) of Congo (Democratic) in 2007 to that in 2013?
Provide a succinct answer. 0.65. What is the ratio of the Value added (current US$) in El Salvador in 2007 to that in 2013?
Offer a terse response. 0.88. What is the ratio of the Value added (current US$) in Kazakhstan in 2007 to that in 2013?
Make the answer very short. 0.48. What is the ratio of the Value added (current US$) in Uzbekistan in 2007 to that in 2013?
Ensure brevity in your answer.  0.31. What is the ratio of the Value added (current US$) of Congo (Democratic) in 2008 to that in 2009?
Your answer should be very brief. 0.98. What is the ratio of the Value added (current US$) of El Salvador in 2008 to that in 2009?
Provide a succinct answer. 1.08. What is the ratio of the Value added (current US$) in Kazakhstan in 2008 to that in 2009?
Offer a terse response. 1.25. What is the ratio of the Value added (current US$) in Uzbekistan in 2008 to that in 2009?
Make the answer very short. 0.94. What is the ratio of the Value added (current US$) in Congo (Democratic) in 2008 to that in 2010?
Make the answer very short. 1.24. What is the ratio of the Value added (current US$) of El Salvador in 2008 to that in 2010?
Offer a terse response. 1.05. What is the ratio of the Value added (current US$) of Kazakhstan in 2008 to that in 2010?
Your answer should be compact. 0.94. What is the ratio of the Value added (current US$) in Uzbekistan in 2008 to that in 2010?
Your answer should be very brief. 0.77. What is the ratio of the Value added (current US$) in Congo (Democratic) in 2008 to that in 2011?
Your response must be concise. 1.09. What is the ratio of the Value added (current US$) of El Salvador in 2008 to that in 2011?
Give a very brief answer. 0.99. What is the ratio of the Value added (current US$) of Kazakhstan in 2008 to that in 2011?
Give a very brief answer. 0.74. What is the ratio of the Value added (current US$) in Uzbekistan in 2008 to that in 2011?
Your answer should be very brief. 0.58. What is the ratio of the Value added (current US$) of Congo (Democratic) in 2008 to that in 2012?
Your response must be concise. 0.96. What is the ratio of the Value added (current US$) of El Salvador in 2008 to that in 2012?
Your answer should be very brief. 0.96. What is the ratio of the Value added (current US$) of Kazakhstan in 2008 to that in 2012?
Make the answer very short. 0.68. What is the ratio of the Value added (current US$) in Uzbekistan in 2008 to that in 2012?
Your response must be concise. 0.49. What is the ratio of the Value added (current US$) of Congo (Democratic) in 2008 to that in 2013?
Make the answer very short. 0.86. What is the ratio of the Value added (current US$) in El Salvador in 2008 to that in 2013?
Ensure brevity in your answer.  0.93. What is the ratio of the Value added (current US$) of Kazakhstan in 2008 to that in 2013?
Provide a short and direct response. 0.62. What is the ratio of the Value added (current US$) in Uzbekistan in 2008 to that in 2013?
Offer a terse response. 0.37. What is the ratio of the Value added (current US$) in Congo (Democratic) in 2009 to that in 2010?
Your answer should be compact. 1.26. What is the ratio of the Value added (current US$) in El Salvador in 2009 to that in 2010?
Provide a short and direct response. 0.97. What is the ratio of the Value added (current US$) in Kazakhstan in 2009 to that in 2010?
Offer a terse response. 0.75. What is the ratio of the Value added (current US$) in Uzbekistan in 2009 to that in 2010?
Your response must be concise. 0.82. What is the ratio of the Value added (current US$) in Congo (Democratic) in 2009 to that in 2011?
Make the answer very short. 1.11. What is the ratio of the Value added (current US$) in El Salvador in 2009 to that in 2011?
Offer a terse response. 0.91. What is the ratio of the Value added (current US$) in Kazakhstan in 2009 to that in 2011?
Offer a terse response. 0.59. What is the ratio of the Value added (current US$) of Uzbekistan in 2009 to that in 2011?
Keep it short and to the point. 0.62. What is the ratio of the Value added (current US$) of El Salvador in 2009 to that in 2012?
Your answer should be compact. 0.89. What is the ratio of the Value added (current US$) in Kazakhstan in 2009 to that in 2012?
Offer a very short reply. 0.54. What is the ratio of the Value added (current US$) in Uzbekistan in 2009 to that in 2012?
Offer a very short reply. 0.52. What is the ratio of the Value added (current US$) in Congo (Democratic) in 2009 to that in 2013?
Make the answer very short. 0.88. What is the ratio of the Value added (current US$) in El Salvador in 2009 to that in 2013?
Provide a short and direct response. 0.86. What is the ratio of the Value added (current US$) of Kazakhstan in 2009 to that in 2013?
Provide a succinct answer. 0.5. What is the ratio of the Value added (current US$) in Uzbekistan in 2009 to that in 2013?
Make the answer very short. 0.39. What is the ratio of the Value added (current US$) in Congo (Democratic) in 2010 to that in 2011?
Your answer should be very brief. 0.88. What is the ratio of the Value added (current US$) in El Salvador in 2010 to that in 2011?
Your response must be concise. 0.94. What is the ratio of the Value added (current US$) in Kazakhstan in 2010 to that in 2011?
Offer a terse response. 0.78. What is the ratio of the Value added (current US$) in Uzbekistan in 2010 to that in 2011?
Provide a short and direct response. 0.76. What is the ratio of the Value added (current US$) in Congo (Democratic) in 2010 to that in 2012?
Offer a terse response. 0.78. What is the ratio of the Value added (current US$) of El Salvador in 2010 to that in 2012?
Your answer should be very brief. 0.92. What is the ratio of the Value added (current US$) in Kazakhstan in 2010 to that in 2012?
Offer a very short reply. 0.73. What is the ratio of the Value added (current US$) in Uzbekistan in 2010 to that in 2012?
Ensure brevity in your answer.  0.63. What is the ratio of the Value added (current US$) of Congo (Democratic) in 2010 to that in 2013?
Keep it short and to the point. 0.7. What is the ratio of the Value added (current US$) in El Salvador in 2010 to that in 2013?
Your answer should be compact. 0.88. What is the ratio of the Value added (current US$) in Kazakhstan in 2010 to that in 2013?
Your answer should be compact. 0.67. What is the ratio of the Value added (current US$) of Uzbekistan in 2010 to that in 2013?
Your answer should be compact. 0.48. What is the ratio of the Value added (current US$) of Congo (Democratic) in 2011 to that in 2012?
Keep it short and to the point. 0.88. What is the ratio of the Value added (current US$) of El Salvador in 2011 to that in 2012?
Offer a terse response. 0.98. What is the ratio of the Value added (current US$) of Kazakhstan in 2011 to that in 2012?
Provide a succinct answer. 0.93. What is the ratio of the Value added (current US$) in Uzbekistan in 2011 to that in 2012?
Make the answer very short. 0.83. What is the ratio of the Value added (current US$) of Congo (Democratic) in 2011 to that in 2013?
Provide a succinct answer. 0.79. What is the ratio of the Value added (current US$) of El Salvador in 2011 to that in 2013?
Offer a very short reply. 0.94. What is the ratio of the Value added (current US$) in Kazakhstan in 2011 to that in 2013?
Provide a short and direct response. 0.85. What is the ratio of the Value added (current US$) in Uzbekistan in 2011 to that in 2013?
Offer a very short reply. 0.63. What is the ratio of the Value added (current US$) of Congo (Democratic) in 2012 to that in 2013?
Your response must be concise. 0.9. What is the ratio of the Value added (current US$) in El Salvador in 2012 to that in 2013?
Provide a short and direct response. 0.96. What is the ratio of the Value added (current US$) in Kazakhstan in 2012 to that in 2013?
Provide a succinct answer. 0.92. What is the ratio of the Value added (current US$) in Uzbekistan in 2012 to that in 2013?
Provide a short and direct response. 0.76. What is the difference between the highest and the second highest Value added (current US$) of Congo (Democratic)?
Your answer should be very brief. 5.25e+08. What is the difference between the highest and the second highest Value added (current US$) of El Salvador?
Your answer should be compact. 1.76e+08. What is the difference between the highest and the second highest Value added (current US$) in Kazakhstan?
Make the answer very short. 2.12e+09. What is the difference between the highest and the second highest Value added (current US$) in Uzbekistan?
Your answer should be compact. 1.36e+09. What is the difference between the highest and the lowest Value added (current US$) in Congo (Democratic)?
Ensure brevity in your answer.  1.75e+09. What is the difference between the highest and the lowest Value added (current US$) of El Salvador?
Offer a very short reply. 6.49e+08. What is the difference between the highest and the lowest Value added (current US$) in Kazakhstan?
Offer a very short reply. 1.31e+1. What is the difference between the highest and the lowest Value added (current US$) in Uzbekistan?
Give a very brief answer. 3.95e+09. 